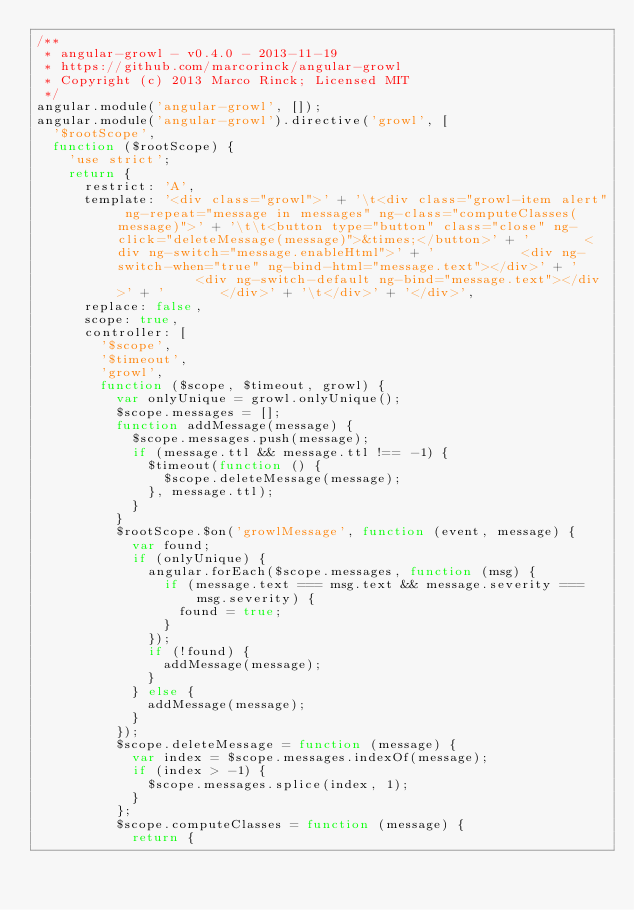<code> <loc_0><loc_0><loc_500><loc_500><_JavaScript_>/**
 * angular-growl - v0.4.0 - 2013-11-19
 * https://github.com/marcorinck/angular-growl
 * Copyright (c) 2013 Marco Rinck; Licensed MIT
 */
angular.module('angular-growl', []);
angular.module('angular-growl').directive('growl', [
  '$rootScope',
  function ($rootScope) {
    'use strict';
    return {
      restrict: 'A',
      template: '<div class="growl">' + '\t<div class="growl-item alert" ng-repeat="message in messages" ng-class="computeClasses(message)">' + '\t\t<button type="button" class="close" ng-click="deleteMessage(message)">&times;</button>' + '       <div ng-switch="message.enableHtml">' + '           <div ng-switch-when="true" ng-bind-html="message.text"></div>' + '           <div ng-switch-default ng-bind="message.text"></div>' + '       </div>' + '\t</div>' + '</div>',
      replace: false,
      scope: true,
      controller: [
        '$scope',
        '$timeout',
        'growl',
        function ($scope, $timeout, growl) {
          var onlyUnique = growl.onlyUnique();
          $scope.messages = [];
          function addMessage(message) {
            $scope.messages.push(message);
            if (message.ttl && message.ttl !== -1) {
              $timeout(function () {
                $scope.deleteMessage(message);
              }, message.ttl);
            }
          }
          $rootScope.$on('growlMessage', function (event, message) {
            var found;
            if (onlyUnique) {
              angular.forEach($scope.messages, function (msg) {
                if (message.text === msg.text && message.severity === msg.severity) {
                  found = true;
                }
              });
              if (!found) {
                addMessage(message);
              }
            } else {
              addMessage(message);
            }
          });
          $scope.deleteMessage = function (message) {
            var index = $scope.messages.indexOf(message);
            if (index > -1) {
              $scope.messages.splice(index, 1);
            }
          };
          $scope.computeClasses = function (message) {
            return {</code> 